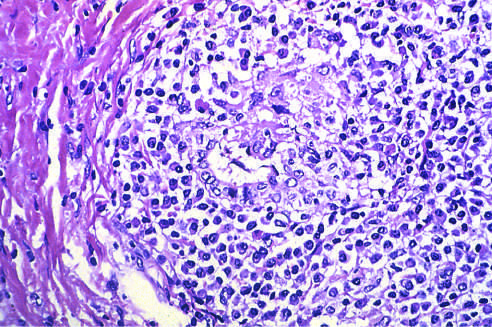what is a portal tract markedly expanded by?
Answer the question using a single word or phrase. An infiltrate of lymphocytes and plasma cells 